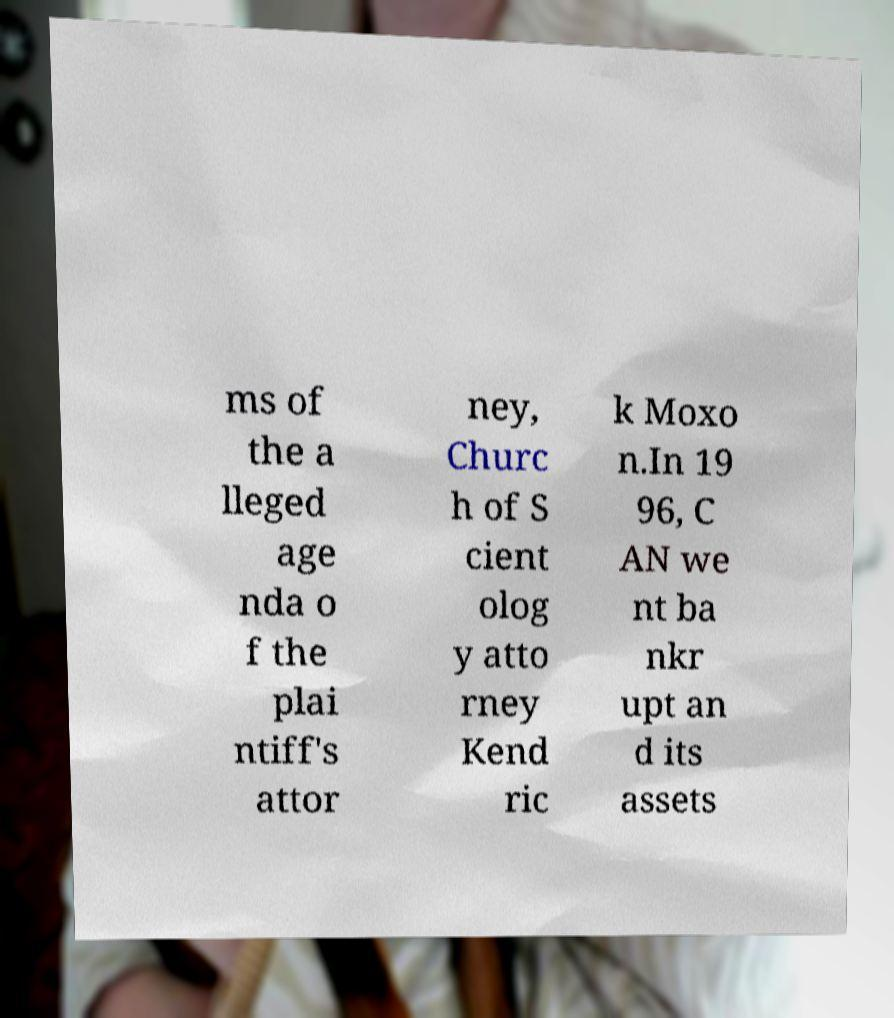For documentation purposes, I need the text within this image transcribed. Could you provide that? ms of the a lleged age nda o f the plai ntiff's attor ney, Churc h of S cient olog y atto rney Kend ric k Moxo n.In 19 96, C AN we nt ba nkr upt an d its assets 